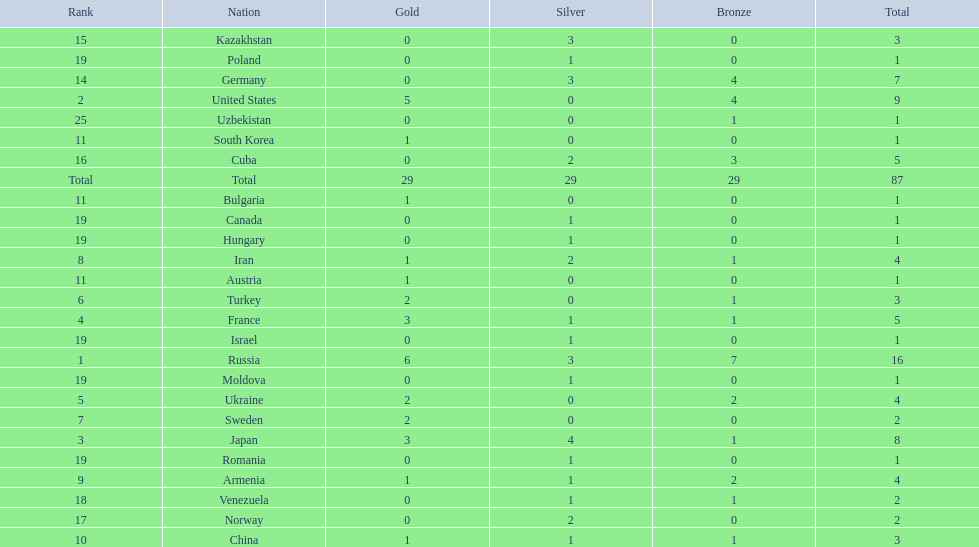How many countries competed? Israel. How many total medals did russia win? 16. What country won only 1 medal? Uzbekistan. 